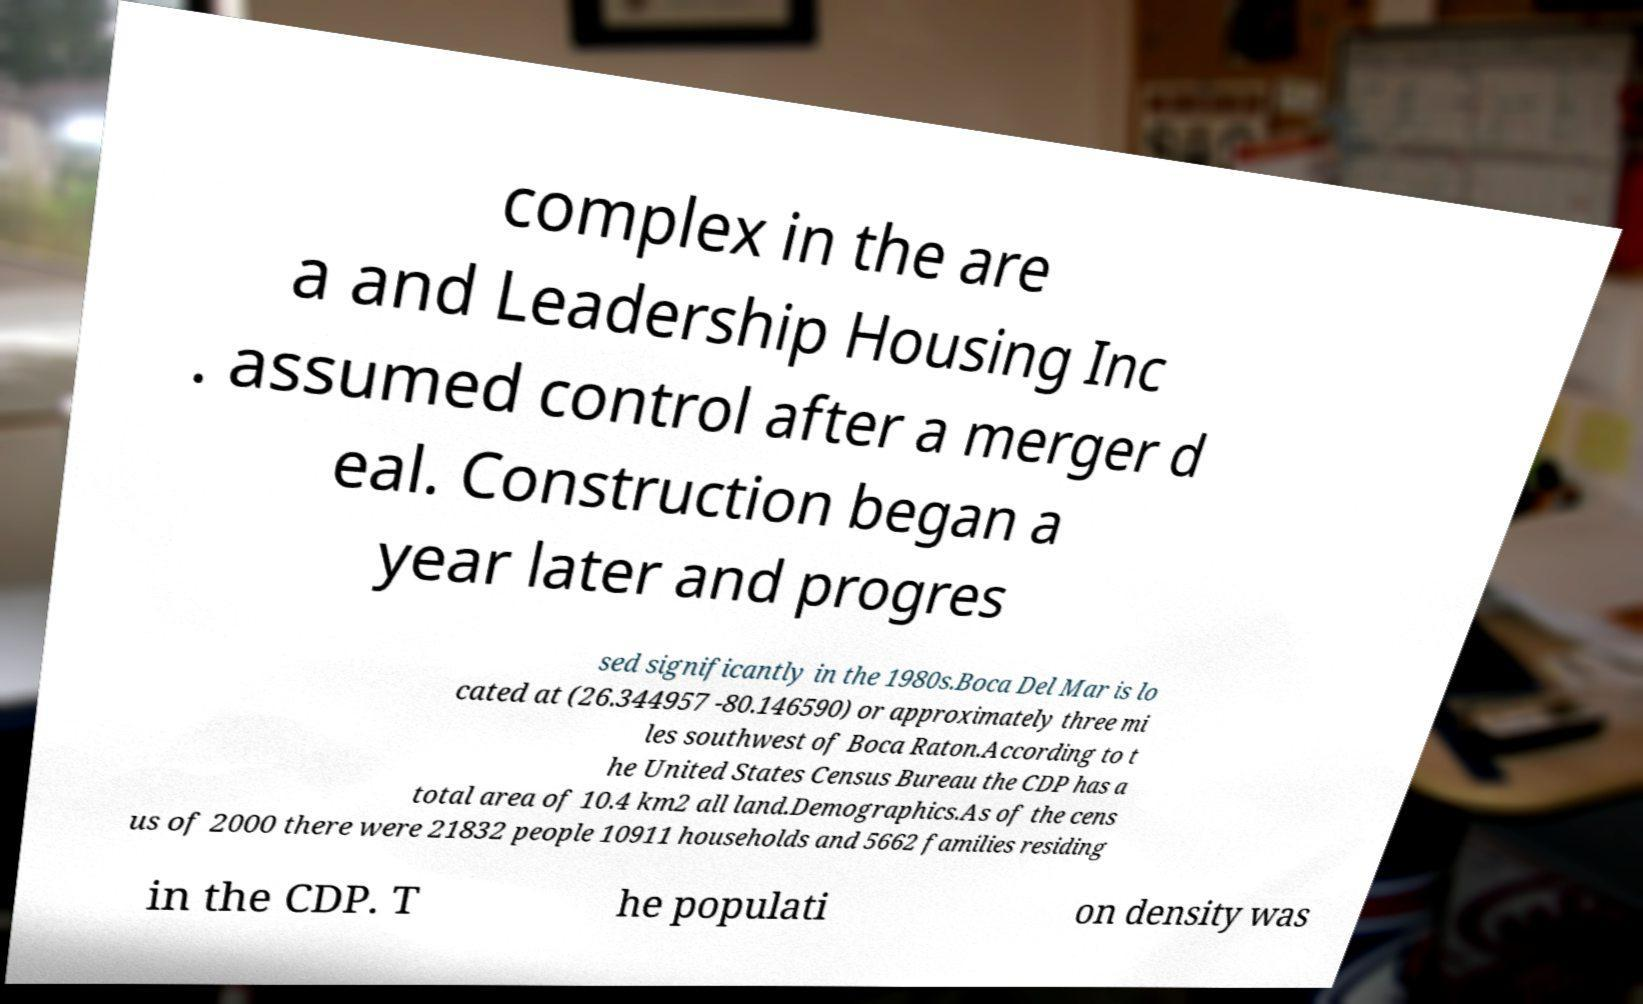Could you extract and type out the text from this image? complex in the are a and Leadership Housing Inc . assumed control after a merger d eal. Construction began a year later and progres sed significantly in the 1980s.Boca Del Mar is lo cated at (26.344957 -80.146590) or approximately three mi les southwest of Boca Raton.According to t he United States Census Bureau the CDP has a total area of 10.4 km2 all land.Demographics.As of the cens us of 2000 there were 21832 people 10911 households and 5662 families residing in the CDP. T he populati on density was 